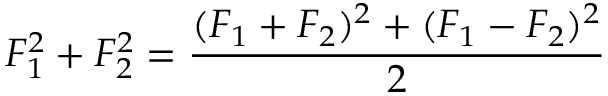<formula> <loc_0><loc_0><loc_500><loc_500>F _ { 1 } ^ { 2 } + F _ { 2 } ^ { 2 } = \frac { ( F _ { 1 } + F _ { 2 } ) ^ { 2 } + ( F _ { 1 } - F _ { 2 } ) ^ { 2 } } { 2 }</formula> 